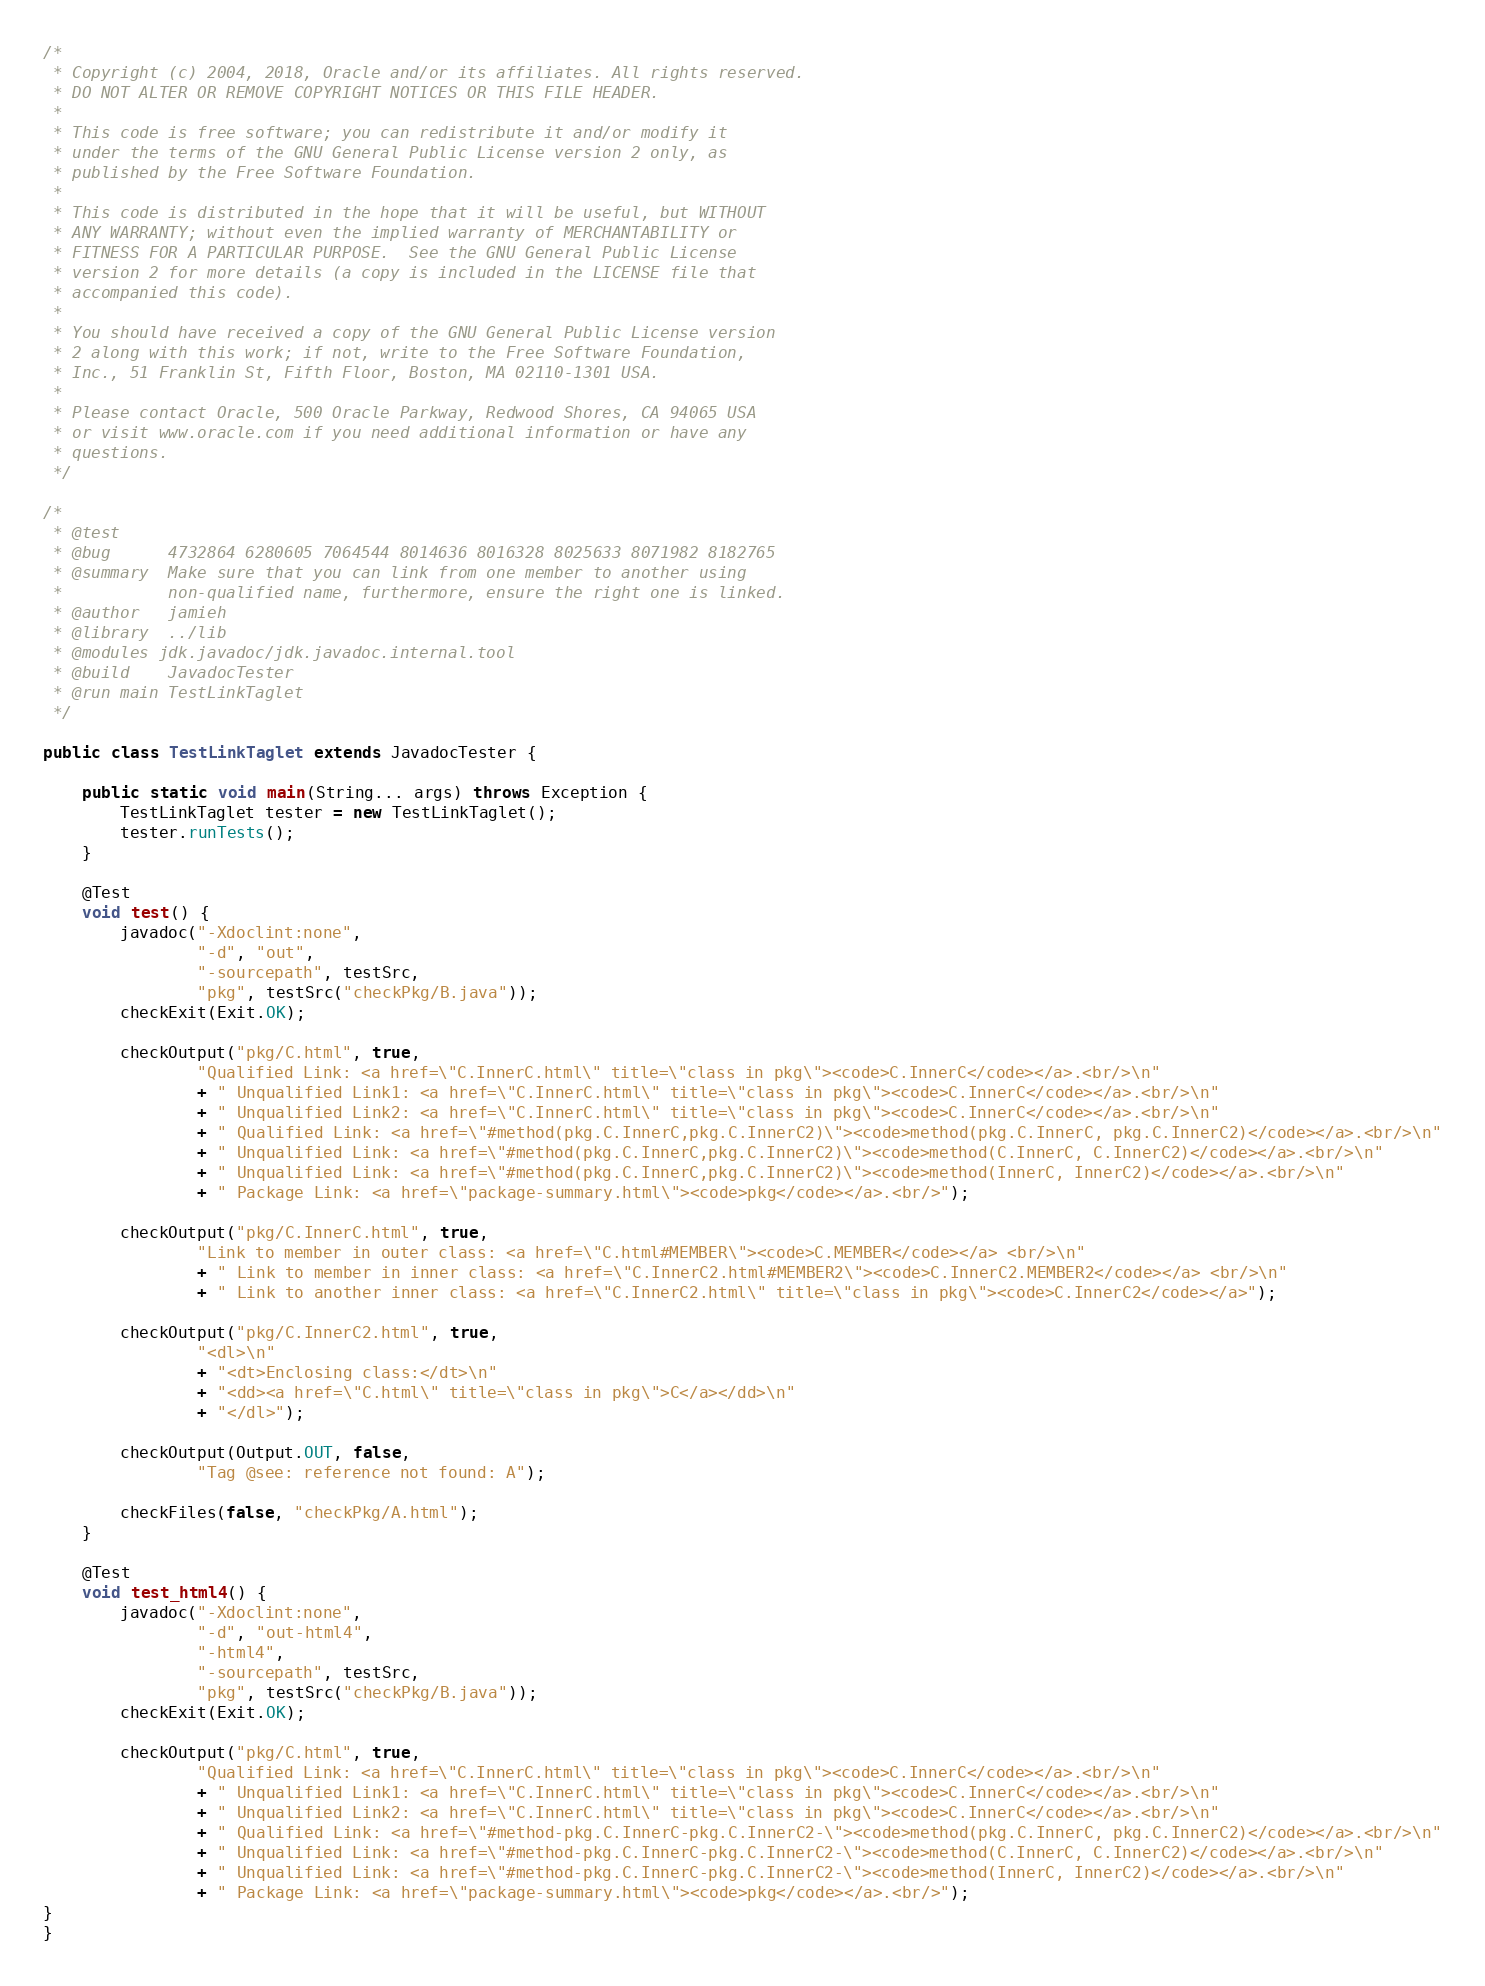Convert code to text. <code><loc_0><loc_0><loc_500><loc_500><_Java_>/*
 * Copyright (c) 2004, 2018, Oracle and/or its affiliates. All rights reserved.
 * DO NOT ALTER OR REMOVE COPYRIGHT NOTICES OR THIS FILE HEADER.
 *
 * This code is free software; you can redistribute it and/or modify it
 * under the terms of the GNU General Public License version 2 only, as
 * published by the Free Software Foundation.
 *
 * This code is distributed in the hope that it will be useful, but WITHOUT
 * ANY WARRANTY; without even the implied warranty of MERCHANTABILITY or
 * FITNESS FOR A PARTICULAR PURPOSE.  See the GNU General Public License
 * version 2 for more details (a copy is included in the LICENSE file that
 * accompanied this code).
 *
 * You should have received a copy of the GNU General Public License version
 * 2 along with this work; if not, write to the Free Software Foundation,
 * Inc., 51 Franklin St, Fifth Floor, Boston, MA 02110-1301 USA.
 *
 * Please contact Oracle, 500 Oracle Parkway, Redwood Shores, CA 94065 USA
 * or visit www.oracle.com if you need additional information or have any
 * questions.
 */

/*
 * @test
 * @bug      4732864 6280605 7064544 8014636 8016328 8025633 8071982 8182765
 * @summary  Make sure that you can link from one member to another using
 *           non-qualified name, furthermore, ensure the right one is linked.
 * @author   jamieh
 * @library  ../lib
 * @modules jdk.javadoc/jdk.javadoc.internal.tool
 * @build    JavadocTester
 * @run main TestLinkTaglet
 */

public class TestLinkTaglet extends JavadocTester {

    public static void main(String... args) throws Exception {
        TestLinkTaglet tester = new TestLinkTaglet();
        tester.runTests();
    }

    @Test
    void test() {
        javadoc("-Xdoclint:none",
                "-d", "out",
                "-sourcepath", testSrc,
                "pkg", testSrc("checkPkg/B.java"));
        checkExit(Exit.OK);

        checkOutput("pkg/C.html", true,
                "Qualified Link: <a href=\"C.InnerC.html\" title=\"class in pkg\"><code>C.InnerC</code></a>.<br/>\n"
                + " Unqualified Link1: <a href=\"C.InnerC.html\" title=\"class in pkg\"><code>C.InnerC</code></a>.<br/>\n"
                + " Unqualified Link2: <a href=\"C.InnerC.html\" title=\"class in pkg\"><code>C.InnerC</code></a>.<br/>\n"
                + " Qualified Link: <a href=\"#method(pkg.C.InnerC,pkg.C.InnerC2)\"><code>method(pkg.C.InnerC, pkg.C.InnerC2)</code></a>.<br/>\n"
                + " Unqualified Link: <a href=\"#method(pkg.C.InnerC,pkg.C.InnerC2)\"><code>method(C.InnerC, C.InnerC2)</code></a>.<br/>\n"
                + " Unqualified Link: <a href=\"#method(pkg.C.InnerC,pkg.C.InnerC2)\"><code>method(InnerC, InnerC2)</code></a>.<br/>\n"
                + " Package Link: <a href=\"package-summary.html\"><code>pkg</code></a>.<br/>");

        checkOutput("pkg/C.InnerC.html", true,
                "Link to member in outer class: <a href=\"C.html#MEMBER\"><code>C.MEMBER</code></a> <br/>\n"
                + " Link to member in inner class: <a href=\"C.InnerC2.html#MEMBER2\"><code>C.InnerC2.MEMBER2</code></a> <br/>\n"
                + " Link to another inner class: <a href=\"C.InnerC2.html\" title=\"class in pkg\"><code>C.InnerC2</code></a>");

        checkOutput("pkg/C.InnerC2.html", true,
                "<dl>\n"
                + "<dt>Enclosing class:</dt>\n"
                + "<dd><a href=\"C.html\" title=\"class in pkg\">C</a></dd>\n"
                + "</dl>");

        checkOutput(Output.OUT, false,
                "Tag @see: reference not found: A");

        checkFiles(false, "checkPkg/A.html");
    }

    @Test
    void test_html4() {
        javadoc("-Xdoclint:none",
                "-d", "out-html4",
                "-html4",
                "-sourcepath", testSrc,
                "pkg", testSrc("checkPkg/B.java"));
        checkExit(Exit.OK);

        checkOutput("pkg/C.html", true,
                "Qualified Link: <a href=\"C.InnerC.html\" title=\"class in pkg\"><code>C.InnerC</code></a>.<br/>\n"
                + " Unqualified Link1: <a href=\"C.InnerC.html\" title=\"class in pkg\"><code>C.InnerC</code></a>.<br/>\n"
                + " Unqualified Link2: <a href=\"C.InnerC.html\" title=\"class in pkg\"><code>C.InnerC</code></a>.<br/>\n"
                + " Qualified Link: <a href=\"#method-pkg.C.InnerC-pkg.C.InnerC2-\"><code>method(pkg.C.InnerC, pkg.C.InnerC2)</code></a>.<br/>\n"
                + " Unqualified Link: <a href=\"#method-pkg.C.InnerC-pkg.C.InnerC2-\"><code>method(C.InnerC, C.InnerC2)</code></a>.<br/>\n"
                + " Unqualified Link: <a href=\"#method-pkg.C.InnerC-pkg.C.InnerC2-\"><code>method(InnerC, InnerC2)</code></a>.<br/>\n"
                + " Package Link: <a href=\"package-summary.html\"><code>pkg</code></a>.<br/>");
}
}
</code> 